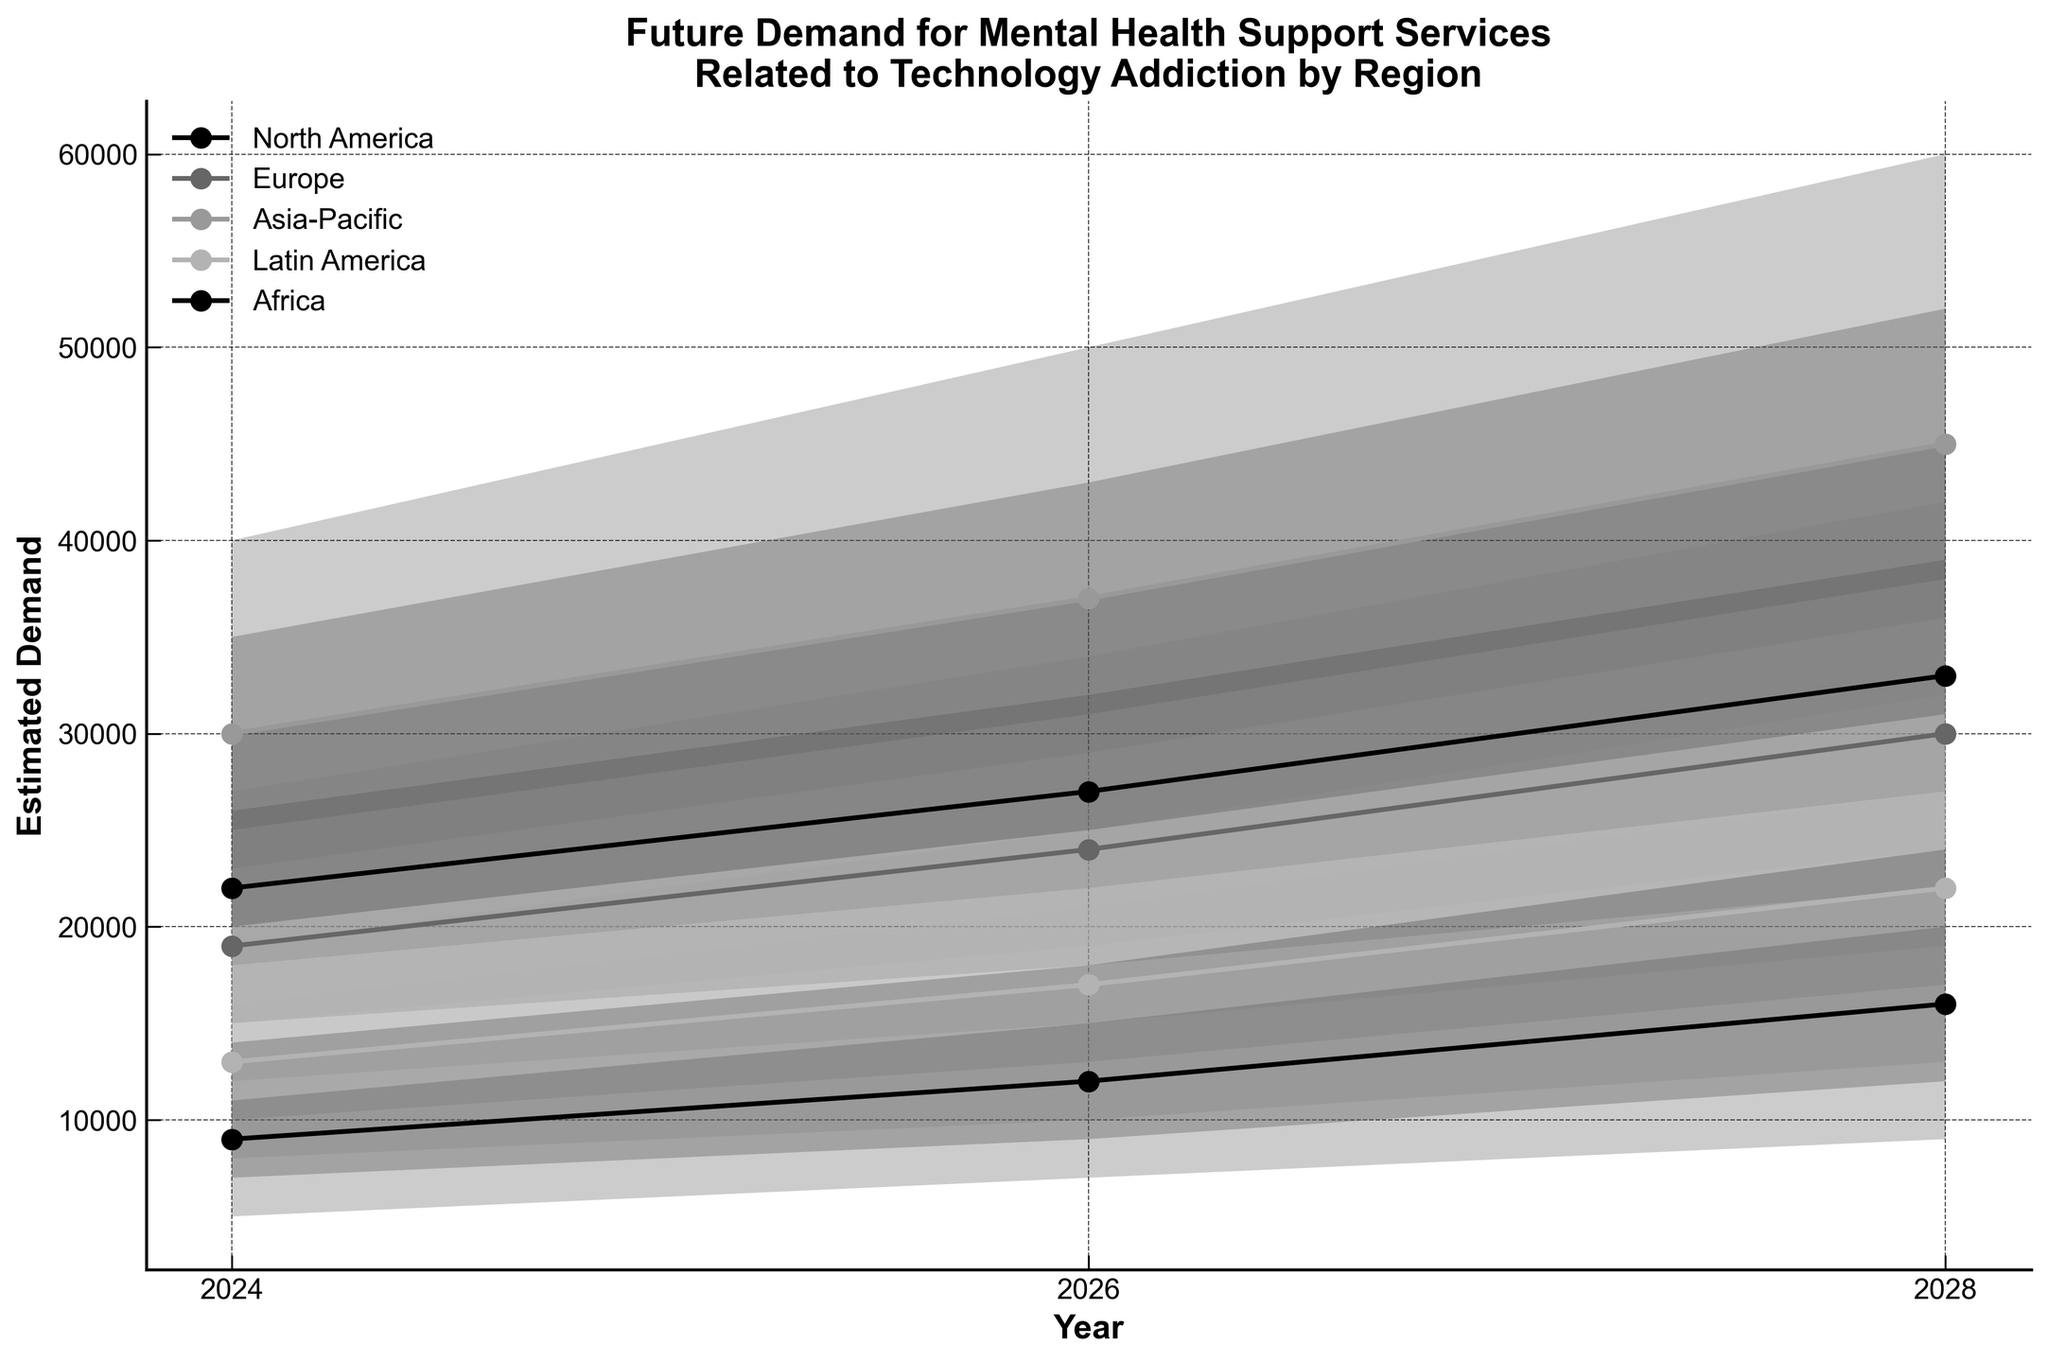what is the title of the chart? The title of the chart can be found at the top. It reads "Future Demand for Mental Health Support Services Related to Technology Addiction by Region".
Answer: Future Demand for Mental Health Support Services Related to Technology Addiction by Region How many unique regions are depicted in the chart? Count the number of unique lines in the legend, each representing a region. There are five unique regions: North America, Europe, Asia-Pacific, Latin America, and Africa.
Answer: 5 In which year does North America see the highest median estimate? By examining the lines and markers for North America, note the median estimate values for different years. North America has the highest median estimate in 2028.
Answer: 2028 What is the range of the high estimates for Asia-Pacific in 2026? Look at the shaded areas for the high estimate in the Asia-Pacific region in 2026. The range is between 37,000 and 50,000.
Answer: 37,000 to 50,000 Which region has the lowest median estimate in 2024 and what is that estimate? Compare the median estimate markers for all regions in 2024. Africa has the lowest median estimate of 9,000.
Answer: Africa, 9,000 What are the low and high estimates for Latin America in 2028? Identify the boundary values of the low and high estimates for Latin America in 2028. They are 13,000 and 32,000, respectively.
Answer: 13,000 and 32,000 What is the median estimate for Europe in 2030, if the trend between 2026 and 2028 continues? Identify the trend for Europe between 2026 (median estimate: 24,000) and 2028 (median estimate: 30,000). The increase is 6,000 over two years, suggesting a median estimate of 36,000 in 2030 if the trend continues.
Answer: 36,000 Which region shows the largest increase in the median estimate from 2024 to 2028? Calculate the difference in median estimates from 2024 to 2028 for each region. Asia-Pacific increases from 30,000 to 45,000, a difference of 15,000, which is the largest increase.
Answer: Asia-Pacific Compare the ranges of mid-high estimates across all regions in 2026. Which region has the largest range? Examine the mid-high estimates in 2026 for each region and subtract the mid-low estimate from the mid-high estimate. Asia-Pacific has the largest range, from 31,000 to 43,000, a range of 12,000.
Answer: Asia-Pacific 